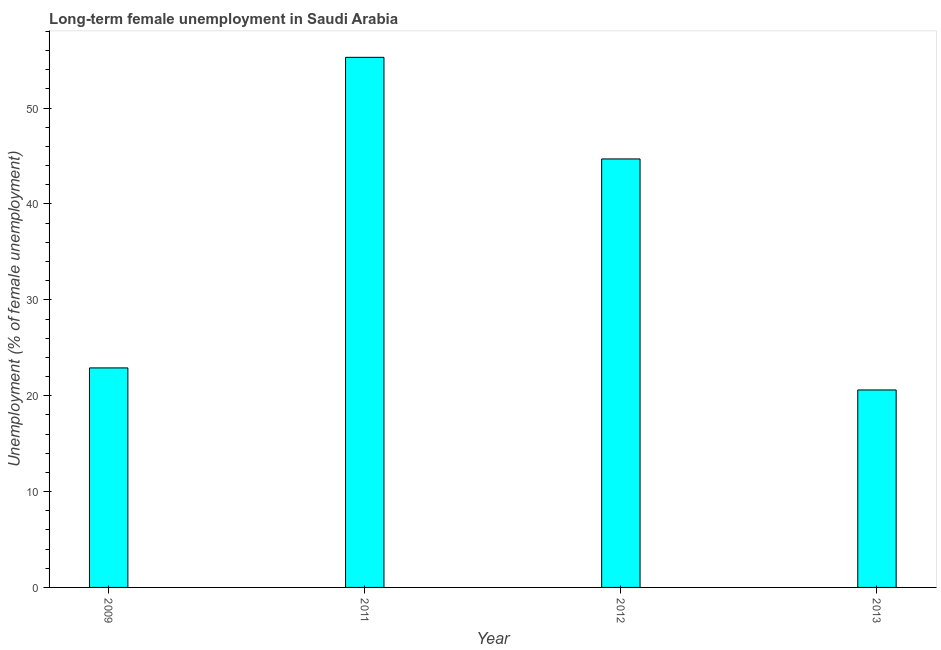Does the graph contain grids?
Your answer should be very brief. No. What is the title of the graph?
Your answer should be compact. Long-term female unemployment in Saudi Arabia. What is the label or title of the Y-axis?
Your answer should be compact. Unemployment (% of female unemployment). What is the long-term female unemployment in 2011?
Keep it short and to the point. 55.3. Across all years, what is the maximum long-term female unemployment?
Provide a short and direct response. 55.3. Across all years, what is the minimum long-term female unemployment?
Keep it short and to the point. 20.6. In which year was the long-term female unemployment minimum?
Keep it short and to the point. 2013. What is the sum of the long-term female unemployment?
Your answer should be very brief. 143.5. What is the average long-term female unemployment per year?
Give a very brief answer. 35.88. What is the median long-term female unemployment?
Offer a very short reply. 33.8. In how many years, is the long-term female unemployment greater than 42 %?
Give a very brief answer. 2. What is the ratio of the long-term female unemployment in 2012 to that in 2013?
Ensure brevity in your answer.  2.17. Is the long-term female unemployment in 2012 less than that in 2013?
Ensure brevity in your answer.  No. What is the difference between the highest and the second highest long-term female unemployment?
Your answer should be very brief. 10.6. What is the difference between the highest and the lowest long-term female unemployment?
Your answer should be very brief. 34.7. How many bars are there?
Keep it short and to the point. 4. What is the difference between two consecutive major ticks on the Y-axis?
Offer a very short reply. 10. What is the Unemployment (% of female unemployment) of 2009?
Ensure brevity in your answer.  22.9. What is the Unemployment (% of female unemployment) of 2011?
Offer a very short reply. 55.3. What is the Unemployment (% of female unemployment) of 2012?
Provide a short and direct response. 44.7. What is the Unemployment (% of female unemployment) of 2013?
Offer a very short reply. 20.6. What is the difference between the Unemployment (% of female unemployment) in 2009 and 2011?
Give a very brief answer. -32.4. What is the difference between the Unemployment (% of female unemployment) in 2009 and 2012?
Offer a terse response. -21.8. What is the difference between the Unemployment (% of female unemployment) in 2011 and 2012?
Ensure brevity in your answer.  10.6. What is the difference between the Unemployment (% of female unemployment) in 2011 and 2013?
Offer a very short reply. 34.7. What is the difference between the Unemployment (% of female unemployment) in 2012 and 2013?
Your answer should be compact. 24.1. What is the ratio of the Unemployment (% of female unemployment) in 2009 to that in 2011?
Give a very brief answer. 0.41. What is the ratio of the Unemployment (% of female unemployment) in 2009 to that in 2012?
Provide a short and direct response. 0.51. What is the ratio of the Unemployment (% of female unemployment) in 2009 to that in 2013?
Make the answer very short. 1.11. What is the ratio of the Unemployment (% of female unemployment) in 2011 to that in 2012?
Your response must be concise. 1.24. What is the ratio of the Unemployment (% of female unemployment) in 2011 to that in 2013?
Offer a very short reply. 2.68. What is the ratio of the Unemployment (% of female unemployment) in 2012 to that in 2013?
Your answer should be very brief. 2.17. 